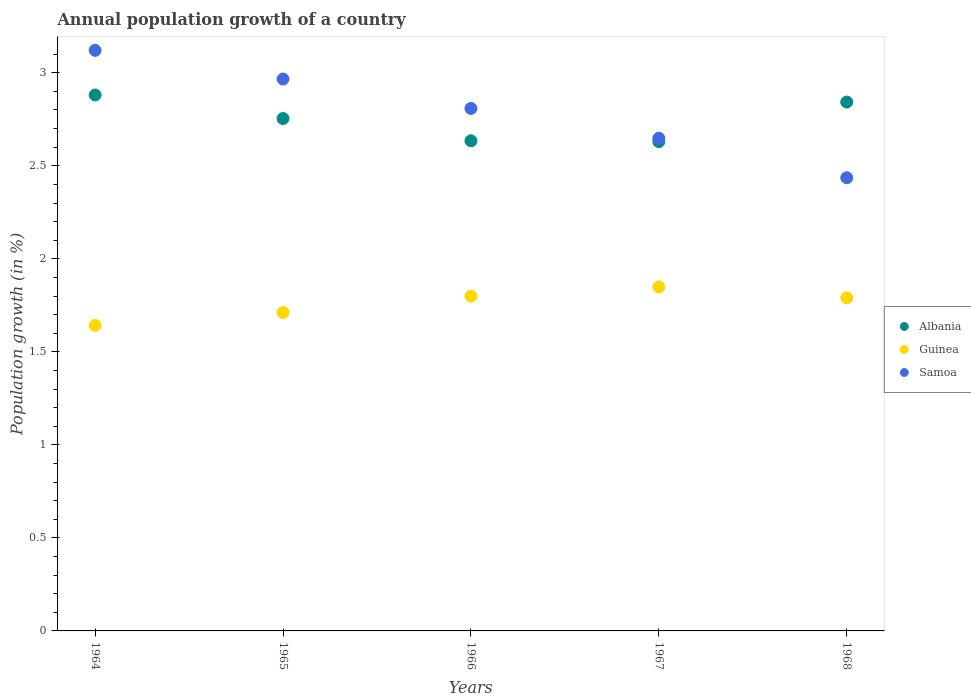Is the number of dotlines equal to the number of legend labels?
Your answer should be very brief. Yes. What is the annual population growth in Samoa in 1965?
Ensure brevity in your answer.  2.97. Across all years, what is the maximum annual population growth in Albania?
Provide a succinct answer. 2.88. Across all years, what is the minimum annual population growth in Albania?
Your response must be concise. 2.63. In which year was the annual population growth in Guinea maximum?
Ensure brevity in your answer.  1967. In which year was the annual population growth in Samoa minimum?
Make the answer very short. 1968. What is the total annual population growth in Guinea in the graph?
Offer a very short reply. 8.79. What is the difference between the annual population growth in Samoa in 1965 and that in 1968?
Make the answer very short. 0.53. What is the difference between the annual population growth in Albania in 1966 and the annual population growth in Guinea in 1965?
Provide a succinct answer. 0.92. What is the average annual population growth in Albania per year?
Your answer should be very brief. 2.75. In the year 1967, what is the difference between the annual population growth in Guinea and annual population growth in Albania?
Your answer should be very brief. -0.78. What is the ratio of the annual population growth in Albania in 1965 to that in 1966?
Your response must be concise. 1.05. What is the difference between the highest and the second highest annual population growth in Guinea?
Give a very brief answer. 0.05. What is the difference between the highest and the lowest annual population growth in Samoa?
Your answer should be very brief. 0.68. In how many years, is the annual population growth in Guinea greater than the average annual population growth in Guinea taken over all years?
Offer a very short reply. 3. Is it the case that in every year, the sum of the annual population growth in Samoa and annual population growth in Guinea  is greater than the annual population growth in Albania?
Your response must be concise. Yes. Does the annual population growth in Albania monotonically increase over the years?
Ensure brevity in your answer.  No. Is the annual population growth in Albania strictly less than the annual population growth in Samoa over the years?
Your answer should be compact. No. How many dotlines are there?
Offer a very short reply. 3. What is the difference between two consecutive major ticks on the Y-axis?
Your answer should be very brief. 0.5. Are the values on the major ticks of Y-axis written in scientific E-notation?
Offer a terse response. No. How are the legend labels stacked?
Your answer should be very brief. Vertical. What is the title of the graph?
Make the answer very short. Annual population growth of a country. Does "Yemen, Rep." appear as one of the legend labels in the graph?
Offer a very short reply. No. What is the label or title of the X-axis?
Provide a succinct answer. Years. What is the label or title of the Y-axis?
Your answer should be very brief. Population growth (in %). What is the Population growth (in %) of Albania in 1964?
Provide a short and direct response. 2.88. What is the Population growth (in %) in Guinea in 1964?
Ensure brevity in your answer.  1.64. What is the Population growth (in %) of Samoa in 1964?
Make the answer very short. 3.12. What is the Population growth (in %) of Albania in 1965?
Provide a short and direct response. 2.75. What is the Population growth (in %) of Guinea in 1965?
Make the answer very short. 1.71. What is the Population growth (in %) in Samoa in 1965?
Offer a very short reply. 2.97. What is the Population growth (in %) in Albania in 1966?
Your answer should be very brief. 2.63. What is the Population growth (in %) in Guinea in 1966?
Keep it short and to the point. 1.8. What is the Population growth (in %) in Samoa in 1966?
Offer a terse response. 2.81. What is the Population growth (in %) in Albania in 1967?
Provide a succinct answer. 2.63. What is the Population growth (in %) of Guinea in 1967?
Make the answer very short. 1.85. What is the Population growth (in %) in Samoa in 1967?
Make the answer very short. 2.65. What is the Population growth (in %) in Albania in 1968?
Provide a short and direct response. 2.84. What is the Population growth (in %) of Guinea in 1968?
Keep it short and to the point. 1.79. What is the Population growth (in %) of Samoa in 1968?
Give a very brief answer. 2.44. Across all years, what is the maximum Population growth (in %) of Albania?
Your answer should be compact. 2.88. Across all years, what is the maximum Population growth (in %) in Guinea?
Make the answer very short. 1.85. Across all years, what is the maximum Population growth (in %) of Samoa?
Provide a succinct answer. 3.12. Across all years, what is the minimum Population growth (in %) of Albania?
Offer a terse response. 2.63. Across all years, what is the minimum Population growth (in %) of Guinea?
Give a very brief answer. 1.64. Across all years, what is the minimum Population growth (in %) of Samoa?
Offer a terse response. 2.44. What is the total Population growth (in %) of Albania in the graph?
Ensure brevity in your answer.  13.74. What is the total Population growth (in %) of Guinea in the graph?
Provide a short and direct response. 8.79. What is the total Population growth (in %) of Samoa in the graph?
Your response must be concise. 13.98. What is the difference between the Population growth (in %) of Albania in 1964 and that in 1965?
Give a very brief answer. 0.13. What is the difference between the Population growth (in %) of Guinea in 1964 and that in 1965?
Your response must be concise. -0.07. What is the difference between the Population growth (in %) in Samoa in 1964 and that in 1965?
Offer a terse response. 0.15. What is the difference between the Population growth (in %) of Albania in 1964 and that in 1966?
Provide a succinct answer. 0.25. What is the difference between the Population growth (in %) of Guinea in 1964 and that in 1966?
Ensure brevity in your answer.  -0.16. What is the difference between the Population growth (in %) in Samoa in 1964 and that in 1966?
Provide a succinct answer. 0.31. What is the difference between the Population growth (in %) in Albania in 1964 and that in 1967?
Offer a very short reply. 0.25. What is the difference between the Population growth (in %) of Guinea in 1964 and that in 1967?
Offer a terse response. -0.21. What is the difference between the Population growth (in %) of Samoa in 1964 and that in 1967?
Offer a terse response. 0.47. What is the difference between the Population growth (in %) in Albania in 1964 and that in 1968?
Provide a short and direct response. 0.04. What is the difference between the Population growth (in %) of Guinea in 1964 and that in 1968?
Keep it short and to the point. -0.15. What is the difference between the Population growth (in %) of Samoa in 1964 and that in 1968?
Provide a succinct answer. 0.68. What is the difference between the Population growth (in %) in Albania in 1965 and that in 1966?
Your answer should be compact. 0.12. What is the difference between the Population growth (in %) in Guinea in 1965 and that in 1966?
Provide a short and direct response. -0.09. What is the difference between the Population growth (in %) in Samoa in 1965 and that in 1966?
Ensure brevity in your answer.  0.16. What is the difference between the Population growth (in %) of Albania in 1965 and that in 1967?
Offer a very short reply. 0.12. What is the difference between the Population growth (in %) of Guinea in 1965 and that in 1967?
Offer a very short reply. -0.14. What is the difference between the Population growth (in %) in Samoa in 1965 and that in 1967?
Give a very brief answer. 0.32. What is the difference between the Population growth (in %) of Albania in 1965 and that in 1968?
Your response must be concise. -0.09. What is the difference between the Population growth (in %) of Guinea in 1965 and that in 1968?
Your answer should be very brief. -0.08. What is the difference between the Population growth (in %) in Samoa in 1965 and that in 1968?
Your answer should be compact. 0.53. What is the difference between the Population growth (in %) of Albania in 1966 and that in 1967?
Ensure brevity in your answer.  0. What is the difference between the Population growth (in %) of Guinea in 1966 and that in 1967?
Provide a succinct answer. -0.05. What is the difference between the Population growth (in %) of Samoa in 1966 and that in 1967?
Your answer should be compact. 0.16. What is the difference between the Population growth (in %) of Albania in 1966 and that in 1968?
Make the answer very short. -0.21. What is the difference between the Population growth (in %) in Guinea in 1966 and that in 1968?
Your answer should be compact. 0.01. What is the difference between the Population growth (in %) of Samoa in 1966 and that in 1968?
Ensure brevity in your answer.  0.37. What is the difference between the Population growth (in %) in Albania in 1967 and that in 1968?
Provide a short and direct response. -0.21. What is the difference between the Population growth (in %) of Guinea in 1967 and that in 1968?
Provide a short and direct response. 0.06. What is the difference between the Population growth (in %) of Samoa in 1967 and that in 1968?
Give a very brief answer. 0.21. What is the difference between the Population growth (in %) of Albania in 1964 and the Population growth (in %) of Guinea in 1965?
Your answer should be very brief. 1.17. What is the difference between the Population growth (in %) of Albania in 1964 and the Population growth (in %) of Samoa in 1965?
Your answer should be compact. -0.09. What is the difference between the Population growth (in %) in Guinea in 1964 and the Population growth (in %) in Samoa in 1965?
Offer a terse response. -1.32. What is the difference between the Population growth (in %) of Albania in 1964 and the Population growth (in %) of Guinea in 1966?
Provide a succinct answer. 1.08. What is the difference between the Population growth (in %) of Albania in 1964 and the Population growth (in %) of Samoa in 1966?
Your answer should be very brief. 0.07. What is the difference between the Population growth (in %) of Guinea in 1964 and the Population growth (in %) of Samoa in 1966?
Keep it short and to the point. -1.17. What is the difference between the Population growth (in %) in Albania in 1964 and the Population growth (in %) in Guinea in 1967?
Keep it short and to the point. 1.03. What is the difference between the Population growth (in %) of Albania in 1964 and the Population growth (in %) of Samoa in 1967?
Your answer should be compact. 0.23. What is the difference between the Population growth (in %) in Guinea in 1964 and the Population growth (in %) in Samoa in 1967?
Give a very brief answer. -1.01. What is the difference between the Population growth (in %) in Albania in 1964 and the Population growth (in %) in Guinea in 1968?
Give a very brief answer. 1.09. What is the difference between the Population growth (in %) of Albania in 1964 and the Population growth (in %) of Samoa in 1968?
Give a very brief answer. 0.44. What is the difference between the Population growth (in %) in Guinea in 1964 and the Population growth (in %) in Samoa in 1968?
Offer a terse response. -0.79. What is the difference between the Population growth (in %) in Albania in 1965 and the Population growth (in %) in Guinea in 1966?
Your response must be concise. 0.95. What is the difference between the Population growth (in %) of Albania in 1965 and the Population growth (in %) of Samoa in 1966?
Offer a terse response. -0.05. What is the difference between the Population growth (in %) of Guinea in 1965 and the Population growth (in %) of Samoa in 1966?
Ensure brevity in your answer.  -1.1. What is the difference between the Population growth (in %) in Albania in 1965 and the Population growth (in %) in Guinea in 1967?
Keep it short and to the point. 0.91. What is the difference between the Population growth (in %) of Albania in 1965 and the Population growth (in %) of Samoa in 1967?
Your answer should be compact. 0.11. What is the difference between the Population growth (in %) of Guinea in 1965 and the Population growth (in %) of Samoa in 1967?
Ensure brevity in your answer.  -0.94. What is the difference between the Population growth (in %) of Albania in 1965 and the Population growth (in %) of Guinea in 1968?
Offer a very short reply. 0.96. What is the difference between the Population growth (in %) in Albania in 1965 and the Population growth (in %) in Samoa in 1968?
Offer a terse response. 0.32. What is the difference between the Population growth (in %) of Guinea in 1965 and the Population growth (in %) of Samoa in 1968?
Offer a terse response. -0.72. What is the difference between the Population growth (in %) of Albania in 1966 and the Population growth (in %) of Guinea in 1967?
Provide a short and direct response. 0.79. What is the difference between the Population growth (in %) in Albania in 1966 and the Population growth (in %) in Samoa in 1967?
Offer a very short reply. -0.01. What is the difference between the Population growth (in %) of Guinea in 1966 and the Population growth (in %) of Samoa in 1967?
Provide a succinct answer. -0.85. What is the difference between the Population growth (in %) of Albania in 1966 and the Population growth (in %) of Guinea in 1968?
Provide a short and direct response. 0.84. What is the difference between the Population growth (in %) in Albania in 1966 and the Population growth (in %) in Samoa in 1968?
Your answer should be compact. 0.2. What is the difference between the Population growth (in %) in Guinea in 1966 and the Population growth (in %) in Samoa in 1968?
Your response must be concise. -0.64. What is the difference between the Population growth (in %) in Albania in 1967 and the Population growth (in %) in Guinea in 1968?
Ensure brevity in your answer.  0.84. What is the difference between the Population growth (in %) in Albania in 1967 and the Population growth (in %) in Samoa in 1968?
Provide a succinct answer. 0.19. What is the difference between the Population growth (in %) of Guinea in 1967 and the Population growth (in %) of Samoa in 1968?
Provide a short and direct response. -0.59. What is the average Population growth (in %) in Albania per year?
Offer a terse response. 2.75. What is the average Population growth (in %) in Guinea per year?
Your answer should be very brief. 1.76. What is the average Population growth (in %) of Samoa per year?
Ensure brevity in your answer.  2.8. In the year 1964, what is the difference between the Population growth (in %) in Albania and Population growth (in %) in Guinea?
Your answer should be compact. 1.24. In the year 1964, what is the difference between the Population growth (in %) of Albania and Population growth (in %) of Samoa?
Your response must be concise. -0.24. In the year 1964, what is the difference between the Population growth (in %) in Guinea and Population growth (in %) in Samoa?
Make the answer very short. -1.48. In the year 1965, what is the difference between the Population growth (in %) in Albania and Population growth (in %) in Guinea?
Provide a succinct answer. 1.04. In the year 1965, what is the difference between the Population growth (in %) of Albania and Population growth (in %) of Samoa?
Provide a succinct answer. -0.21. In the year 1965, what is the difference between the Population growth (in %) of Guinea and Population growth (in %) of Samoa?
Make the answer very short. -1.25. In the year 1966, what is the difference between the Population growth (in %) in Albania and Population growth (in %) in Guinea?
Your answer should be compact. 0.84. In the year 1966, what is the difference between the Population growth (in %) of Albania and Population growth (in %) of Samoa?
Provide a succinct answer. -0.17. In the year 1966, what is the difference between the Population growth (in %) of Guinea and Population growth (in %) of Samoa?
Provide a short and direct response. -1.01. In the year 1967, what is the difference between the Population growth (in %) of Albania and Population growth (in %) of Guinea?
Your answer should be very brief. 0.78. In the year 1967, what is the difference between the Population growth (in %) of Albania and Population growth (in %) of Samoa?
Provide a succinct answer. -0.02. In the year 1967, what is the difference between the Population growth (in %) in Guinea and Population growth (in %) in Samoa?
Your response must be concise. -0.8. In the year 1968, what is the difference between the Population growth (in %) of Albania and Population growth (in %) of Guinea?
Provide a short and direct response. 1.05. In the year 1968, what is the difference between the Population growth (in %) of Albania and Population growth (in %) of Samoa?
Provide a succinct answer. 0.41. In the year 1968, what is the difference between the Population growth (in %) in Guinea and Population growth (in %) in Samoa?
Your response must be concise. -0.65. What is the ratio of the Population growth (in %) of Albania in 1964 to that in 1965?
Keep it short and to the point. 1.05. What is the ratio of the Population growth (in %) in Guinea in 1964 to that in 1965?
Provide a succinct answer. 0.96. What is the ratio of the Population growth (in %) in Samoa in 1964 to that in 1965?
Your response must be concise. 1.05. What is the ratio of the Population growth (in %) of Albania in 1964 to that in 1966?
Keep it short and to the point. 1.09. What is the ratio of the Population growth (in %) in Guinea in 1964 to that in 1966?
Ensure brevity in your answer.  0.91. What is the ratio of the Population growth (in %) of Samoa in 1964 to that in 1966?
Your response must be concise. 1.11. What is the ratio of the Population growth (in %) in Albania in 1964 to that in 1967?
Keep it short and to the point. 1.1. What is the ratio of the Population growth (in %) of Guinea in 1964 to that in 1967?
Provide a short and direct response. 0.89. What is the ratio of the Population growth (in %) of Samoa in 1964 to that in 1967?
Offer a terse response. 1.18. What is the ratio of the Population growth (in %) of Albania in 1964 to that in 1968?
Make the answer very short. 1.01. What is the ratio of the Population growth (in %) of Guinea in 1964 to that in 1968?
Provide a short and direct response. 0.92. What is the ratio of the Population growth (in %) in Samoa in 1964 to that in 1968?
Your response must be concise. 1.28. What is the ratio of the Population growth (in %) of Albania in 1965 to that in 1966?
Offer a terse response. 1.05. What is the ratio of the Population growth (in %) of Guinea in 1965 to that in 1966?
Your answer should be very brief. 0.95. What is the ratio of the Population growth (in %) of Samoa in 1965 to that in 1966?
Your answer should be very brief. 1.06. What is the ratio of the Population growth (in %) in Albania in 1965 to that in 1967?
Provide a succinct answer. 1.05. What is the ratio of the Population growth (in %) in Guinea in 1965 to that in 1967?
Offer a terse response. 0.93. What is the ratio of the Population growth (in %) of Samoa in 1965 to that in 1967?
Keep it short and to the point. 1.12. What is the ratio of the Population growth (in %) of Albania in 1965 to that in 1968?
Your answer should be compact. 0.97. What is the ratio of the Population growth (in %) of Guinea in 1965 to that in 1968?
Your answer should be compact. 0.96. What is the ratio of the Population growth (in %) in Samoa in 1965 to that in 1968?
Offer a terse response. 1.22. What is the ratio of the Population growth (in %) of Albania in 1966 to that in 1967?
Give a very brief answer. 1. What is the ratio of the Population growth (in %) in Guinea in 1966 to that in 1967?
Keep it short and to the point. 0.97. What is the ratio of the Population growth (in %) in Samoa in 1966 to that in 1967?
Offer a terse response. 1.06. What is the ratio of the Population growth (in %) of Albania in 1966 to that in 1968?
Provide a short and direct response. 0.93. What is the ratio of the Population growth (in %) of Samoa in 1966 to that in 1968?
Provide a short and direct response. 1.15. What is the ratio of the Population growth (in %) in Albania in 1967 to that in 1968?
Your answer should be compact. 0.93. What is the ratio of the Population growth (in %) in Guinea in 1967 to that in 1968?
Your answer should be compact. 1.03. What is the ratio of the Population growth (in %) of Samoa in 1967 to that in 1968?
Your answer should be very brief. 1.09. What is the difference between the highest and the second highest Population growth (in %) in Albania?
Offer a very short reply. 0.04. What is the difference between the highest and the second highest Population growth (in %) in Guinea?
Offer a very short reply. 0.05. What is the difference between the highest and the second highest Population growth (in %) in Samoa?
Provide a succinct answer. 0.15. What is the difference between the highest and the lowest Population growth (in %) of Albania?
Ensure brevity in your answer.  0.25. What is the difference between the highest and the lowest Population growth (in %) in Guinea?
Your answer should be very brief. 0.21. What is the difference between the highest and the lowest Population growth (in %) of Samoa?
Provide a short and direct response. 0.68. 